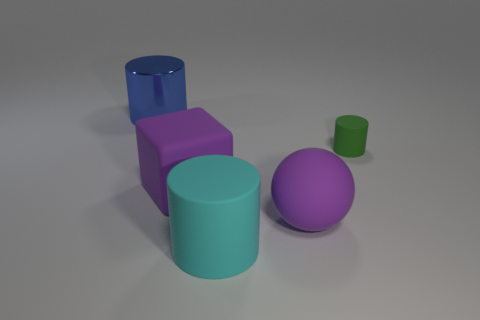Add 1 brown metallic things. How many objects exist? 6 Subtract all balls. How many objects are left? 4 Subtract 0 green spheres. How many objects are left? 5 Subtract all blue cylinders. Subtract all cubes. How many objects are left? 3 Add 3 blue metallic cylinders. How many blue metallic cylinders are left? 4 Add 1 large purple matte things. How many large purple matte things exist? 3 